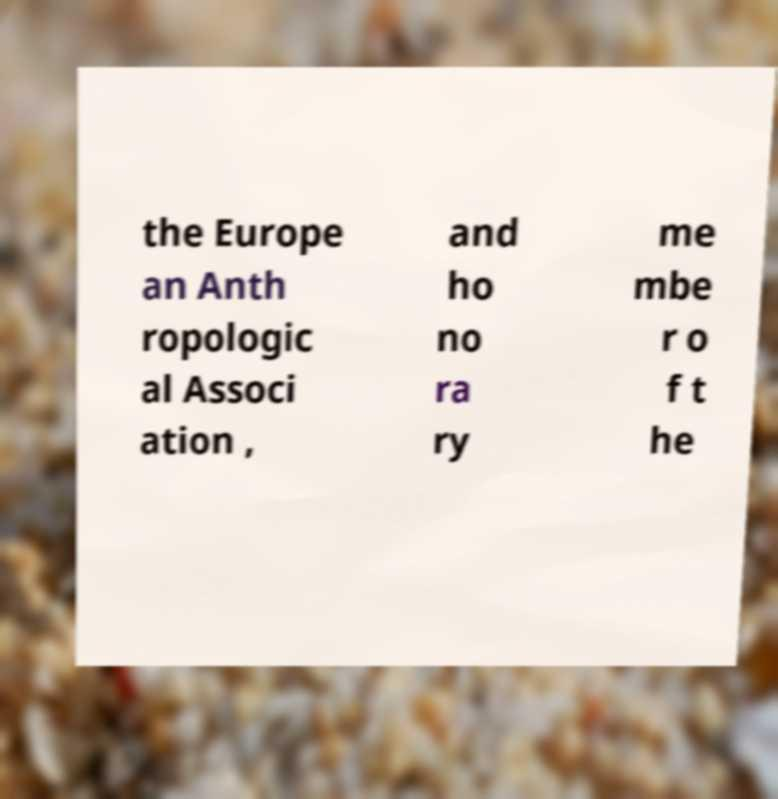Can you accurately transcribe the text from the provided image for me? the Europe an Anth ropologic al Associ ation , and ho no ra ry me mbe r o f t he 